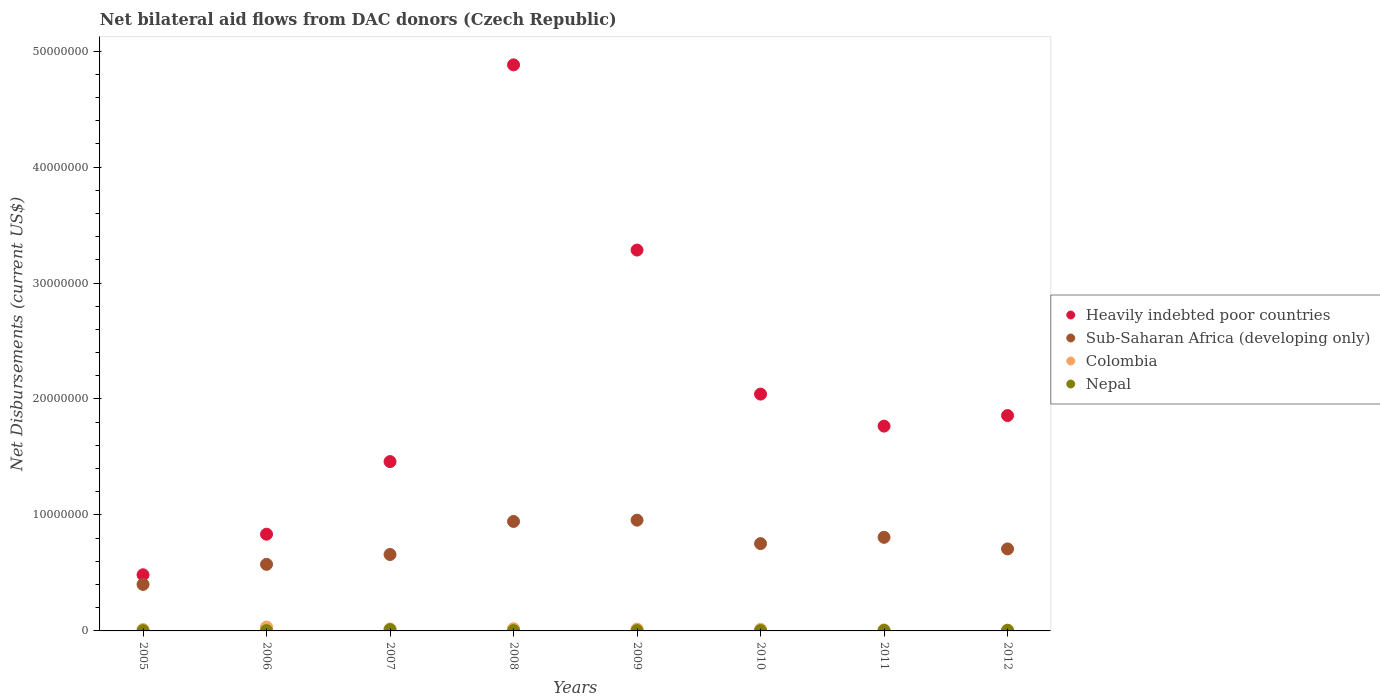How many different coloured dotlines are there?
Give a very brief answer. 4. Is the number of dotlines equal to the number of legend labels?
Keep it short and to the point. Yes. What is the net bilateral aid flows in Colombia in 2010?
Ensure brevity in your answer.  1.40e+05. Across all years, what is the maximum net bilateral aid flows in Colombia?
Make the answer very short. 3.30e+05. Across all years, what is the minimum net bilateral aid flows in Nepal?
Keep it short and to the point. 2.00e+04. In which year was the net bilateral aid flows in Sub-Saharan Africa (developing only) maximum?
Provide a succinct answer. 2009. What is the total net bilateral aid flows in Colombia in the graph?
Provide a short and direct response. 1.27e+06. What is the difference between the net bilateral aid flows in Heavily indebted poor countries in 2011 and that in 2012?
Keep it short and to the point. -9.10e+05. What is the difference between the net bilateral aid flows in Sub-Saharan Africa (developing only) in 2006 and the net bilateral aid flows in Colombia in 2010?
Give a very brief answer. 5.60e+06. What is the average net bilateral aid flows in Colombia per year?
Your response must be concise. 1.59e+05. In the year 2010, what is the difference between the net bilateral aid flows in Colombia and net bilateral aid flows in Nepal?
Provide a succinct answer. 1.10e+05. What is the ratio of the net bilateral aid flows in Colombia in 2007 to that in 2010?
Give a very brief answer. 1.21. Is the difference between the net bilateral aid flows in Colombia in 2009 and 2010 greater than the difference between the net bilateral aid flows in Nepal in 2009 and 2010?
Make the answer very short. Yes. What is the difference between the highest and the lowest net bilateral aid flows in Heavily indebted poor countries?
Provide a short and direct response. 4.40e+07. In how many years, is the net bilateral aid flows in Sub-Saharan Africa (developing only) greater than the average net bilateral aid flows in Sub-Saharan Africa (developing only) taken over all years?
Make the answer very short. 4. Is it the case that in every year, the sum of the net bilateral aid flows in Colombia and net bilateral aid flows in Nepal  is greater than the sum of net bilateral aid flows in Sub-Saharan Africa (developing only) and net bilateral aid flows in Heavily indebted poor countries?
Make the answer very short. Yes. Is it the case that in every year, the sum of the net bilateral aid flows in Heavily indebted poor countries and net bilateral aid flows in Sub-Saharan Africa (developing only)  is greater than the net bilateral aid flows in Nepal?
Provide a short and direct response. Yes. Is the net bilateral aid flows in Sub-Saharan Africa (developing only) strictly less than the net bilateral aid flows in Colombia over the years?
Your answer should be very brief. No. Does the graph contain any zero values?
Give a very brief answer. No. Does the graph contain grids?
Your response must be concise. No. How are the legend labels stacked?
Keep it short and to the point. Vertical. What is the title of the graph?
Your answer should be very brief. Net bilateral aid flows from DAC donors (Czech Republic). What is the label or title of the X-axis?
Make the answer very short. Years. What is the label or title of the Y-axis?
Offer a very short reply. Net Disbursements (current US$). What is the Net Disbursements (current US$) of Heavily indebted poor countries in 2005?
Make the answer very short. 4.84e+06. What is the Net Disbursements (current US$) in Sub-Saharan Africa (developing only) in 2005?
Offer a very short reply. 4.01e+06. What is the Net Disbursements (current US$) of Heavily indebted poor countries in 2006?
Provide a short and direct response. 8.34e+06. What is the Net Disbursements (current US$) of Sub-Saharan Africa (developing only) in 2006?
Your response must be concise. 5.74e+06. What is the Net Disbursements (current US$) in Nepal in 2006?
Your answer should be compact. 3.00e+04. What is the Net Disbursements (current US$) in Heavily indebted poor countries in 2007?
Keep it short and to the point. 1.46e+07. What is the Net Disbursements (current US$) of Sub-Saharan Africa (developing only) in 2007?
Your answer should be compact. 6.59e+06. What is the Net Disbursements (current US$) of Heavily indebted poor countries in 2008?
Provide a short and direct response. 4.88e+07. What is the Net Disbursements (current US$) in Sub-Saharan Africa (developing only) in 2008?
Your answer should be very brief. 9.44e+06. What is the Net Disbursements (current US$) in Colombia in 2008?
Offer a very short reply. 1.90e+05. What is the Net Disbursements (current US$) in Nepal in 2008?
Offer a very short reply. 3.00e+04. What is the Net Disbursements (current US$) of Heavily indebted poor countries in 2009?
Provide a succinct answer. 3.28e+07. What is the Net Disbursements (current US$) in Sub-Saharan Africa (developing only) in 2009?
Offer a terse response. 9.55e+06. What is the Net Disbursements (current US$) in Heavily indebted poor countries in 2010?
Your response must be concise. 2.04e+07. What is the Net Disbursements (current US$) of Sub-Saharan Africa (developing only) in 2010?
Your response must be concise. 7.53e+06. What is the Net Disbursements (current US$) of Heavily indebted poor countries in 2011?
Offer a very short reply. 1.77e+07. What is the Net Disbursements (current US$) in Sub-Saharan Africa (developing only) in 2011?
Keep it short and to the point. 8.07e+06. What is the Net Disbursements (current US$) in Colombia in 2011?
Offer a terse response. 9.00e+04. What is the Net Disbursements (current US$) in Heavily indebted poor countries in 2012?
Provide a short and direct response. 1.86e+07. What is the Net Disbursements (current US$) in Sub-Saharan Africa (developing only) in 2012?
Your response must be concise. 7.07e+06. What is the Net Disbursements (current US$) in Colombia in 2012?
Offer a terse response. 7.00e+04. What is the Net Disbursements (current US$) of Nepal in 2012?
Give a very brief answer. 5.00e+04. Across all years, what is the maximum Net Disbursements (current US$) in Heavily indebted poor countries?
Keep it short and to the point. 4.88e+07. Across all years, what is the maximum Net Disbursements (current US$) of Sub-Saharan Africa (developing only)?
Your response must be concise. 9.55e+06. Across all years, what is the maximum Net Disbursements (current US$) of Colombia?
Offer a very short reply. 3.30e+05. Across all years, what is the minimum Net Disbursements (current US$) in Heavily indebted poor countries?
Ensure brevity in your answer.  4.84e+06. Across all years, what is the minimum Net Disbursements (current US$) in Sub-Saharan Africa (developing only)?
Provide a short and direct response. 4.01e+06. Across all years, what is the minimum Net Disbursements (current US$) of Colombia?
Make the answer very short. 7.00e+04. Across all years, what is the minimum Net Disbursements (current US$) of Nepal?
Provide a succinct answer. 2.00e+04. What is the total Net Disbursements (current US$) of Heavily indebted poor countries in the graph?
Your answer should be very brief. 1.66e+08. What is the total Net Disbursements (current US$) of Sub-Saharan Africa (developing only) in the graph?
Give a very brief answer. 5.80e+07. What is the total Net Disbursements (current US$) of Colombia in the graph?
Your answer should be very brief. 1.27e+06. What is the difference between the Net Disbursements (current US$) in Heavily indebted poor countries in 2005 and that in 2006?
Your answer should be very brief. -3.50e+06. What is the difference between the Net Disbursements (current US$) of Sub-Saharan Africa (developing only) in 2005 and that in 2006?
Offer a very short reply. -1.73e+06. What is the difference between the Net Disbursements (current US$) in Colombia in 2005 and that in 2006?
Your response must be concise. -2.10e+05. What is the difference between the Net Disbursements (current US$) in Nepal in 2005 and that in 2006?
Your answer should be compact. -10000. What is the difference between the Net Disbursements (current US$) of Heavily indebted poor countries in 2005 and that in 2007?
Offer a terse response. -9.76e+06. What is the difference between the Net Disbursements (current US$) of Sub-Saharan Africa (developing only) in 2005 and that in 2007?
Give a very brief answer. -2.58e+06. What is the difference between the Net Disbursements (current US$) in Heavily indebted poor countries in 2005 and that in 2008?
Offer a terse response. -4.40e+07. What is the difference between the Net Disbursements (current US$) of Sub-Saharan Africa (developing only) in 2005 and that in 2008?
Your answer should be very brief. -5.43e+06. What is the difference between the Net Disbursements (current US$) of Heavily indebted poor countries in 2005 and that in 2009?
Keep it short and to the point. -2.80e+07. What is the difference between the Net Disbursements (current US$) of Sub-Saharan Africa (developing only) in 2005 and that in 2009?
Provide a short and direct response. -5.54e+06. What is the difference between the Net Disbursements (current US$) in Heavily indebted poor countries in 2005 and that in 2010?
Your response must be concise. -1.56e+07. What is the difference between the Net Disbursements (current US$) of Sub-Saharan Africa (developing only) in 2005 and that in 2010?
Keep it short and to the point. -3.52e+06. What is the difference between the Net Disbursements (current US$) in Colombia in 2005 and that in 2010?
Your answer should be compact. -2.00e+04. What is the difference between the Net Disbursements (current US$) in Nepal in 2005 and that in 2010?
Your response must be concise. -10000. What is the difference between the Net Disbursements (current US$) of Heavily indebted poor countries in 2005 and that in 2011?
Offer a terse response. -1.28e+07. What is the difference between the Net Disbursements (current US$) in Sub-Saharan Africa (developing only) in 2005 and that in 2011?
Your response must be concise. -4.06e+06. What is the difference between the Net Disbursements (current US$) of Colombia in 2005 and that in 2011?
Your answer should be compact. 3.00e+04. What is the difference between the Net Disbursements (current US$) of Heavily indebted poor countries in 2005 and that in 2012?
Keep it short and to the point. -1.37e+07. What is the difference between the Net Disbursements (current US$) of Sub-Saharan Africa (developing only) in 2005 and that in 2012?
Provide a succinct answer. -3.06e+06. What is the difference between the Net Disbursements (current US$) of Heavily indebted poor countries in 2006 and that in 2007?
Provide a succinct answer. -6.26e+06. What is the difference between the Net Disbursements (current US$) in Sub-Saharan Africa (developing only) in 2006 and that in 2007?
Give a very brief answer. -8.50e+05. What is the difference between the Net Disbursements (current US$) in Heavily indebted poor countries in 2006 and that in 2008?
Make the answer very short. -4.05e+07. What is the difference between the Net Disbursements (current US$) in Sub-Saharan Africa (developing only) in 2006 and that in 2008?
Give a very brief answer. -3.70e+06. What is the difference between the Net Disbursements (current US$) in Colombia in 2006 and that in 2008?
Your answer should be very brief. 1.40e+05. What is the difference between the Net Disbursements (current US$) in Heavily indebted poor countries in 2006 and that in 2009?
Make the answer very short. -2.45e+07. What is the difference between the Net Disbursements (current US$) of Sub-Saharan Africa (developing only) in 2006 and that in 2009?
Keep it short and to the point. -3.81e+06. What is the difference between the Net Disbursements (current US$) in Colombia in 2006 and that in 2009?
Your answer should be very brief. 1.70e+05. What is the difference between the Net Disbursements (current US$) of Heavily indebted poor countries in 2006 and that in 2010?
Keep it short and to the point. -1.21e+07. What is the difference between the Net Disbursements (current US$) in Sub-Saharan Africa (developing only) in 2006 and that in 2010?
Keep it short and to the point. -1.79e+06. What is the difference between the Net Disbursements (current US$) of Colombia in 2006 and that in 2010?
Make the answer very short. 1.90e+05. What is the difference between the Net Disbursements (current US$) in Nepal in 2006 and that in 2010?
Your response must be concise. 0. What is the difference between the Net Disbursements (current US$) in Heavily indebted poor countries in 2006 and that in 2011?
Offer a terse response. -9.32e+06. What is the difference between the Net Disbursements (current US$) in Sub-Saharan Africa (developing only) in 2006 and that in 2011?
Provide a succinct answer. -2.33e+06. What is the difference between the Net Disbursements (current US$) in Colombia in 2006 and that in 2011?
Ensure brevity in your answer.  2.40e+05. What is the difference between the Net Disbursements (current US$) in Nepal in 2006 and that in 2011?
Your answer should be very brief. -10000. What is the difference between the Net Disbursements (current US$) in Heavily indebted poor countries in 2006 and that in 2012?
Offer a very short reply. -1.02e+07. What is the difference between the Net Disbursements (current US$) in Sub-Saharan Africa (developing only) in 2006 and that in 2012?
Offer a terse response. -1.33e+06. What is the difference between the Net Disbursements (current US$) of Nepal in 2006 and that in 2012?
Offer a very short reply. -2.00e+04. What is the difference between the Net Disbursements (current US$) of Heavily indebted poor countries in 2007 and that in 2008?
Make the answer very short. -3.42e+07. What is the difference between the Net Disbursements (current US$) of Sub-Saharan Africa (developing only) in 2007 and that in 2008?
Offer a terse response. -2.85e+06. What is the difference between the Net Disbursements (current US$) in Nepal in 2007 and that in 2008?
Give a very brief answer. 8.00e+04. What is the difference between the Net Disbursements (current US$) of Heavily indebted poor countries in 2007 and that in 2009?
Your answer should be compact. -1.82e+07. What is the difference between the Net Disbursements (current US$) of Sub-Saharan Africa (developing only) in 2007 and that in 2009?
Provide a short and direct response. -2.96e+06. What is the difference between the Net Disbursements (current US$) in Colombia in 2007 and that in 2009?
Offer a terse response. 10000. What is the difference between the Net Disbursements (current US$) of Nepal in 2007 and that in 2009?
Your answer should be compact. 8.00e+04. What is the difference between the Net Disbursements (current US$) of Heavily indebted poor countries in 2007 and that in 2010?
Make the answer very short. -5.82e+06. What is the difference between the Net Disbursements (current US$) of Sub-Saharan Africa (developing only) in 2007 and that in 2010?
Offer a very short reply. -9.40e+05. What is the difference between the Net Disbursements (current US$) of Colombia in 2007 and that in 2010?
Give a very brief answer. 3.00e+04. What is the difference between the Net Disbursements (current US$) in Heavily indebted poor countries in 2007 and that in 2011?
Make the answer very short. -3.06e+06. What is the difference between the Net Disbursements (current US$) of Sub-Saharan Africa (developing only) in 2007 and that in 2011?
Your response must be concise. -1.48e+06. What is the difference between the Net Disbursements (current US$) in Nepal in 2007 and that in 2011?
Offer a very short reply. 7.00e+04. What is the difference between the Net Disbursements (current US$) in Heavily indebted poor countries in 2007 and that in 2012?
Your answer should be very brief. -3.97e+06. What is the difference between the Net Disbursements (current US$) of Sub-Saharan Africa (developing only) in 2007 and that in 2012?
Your answer should be compact. -4.80e+05. What is the difference between the Net Disbursements (current US$) in Nepal in 2007 and that in 2012?
Offer a very short reply. 6.00e+04. What is the difference between the Net Disbursements (current US$) of Heavily indebted poor countries in 2008 and that in 2009?
Your answer should be very brief. 1.60e+07. What is the difference between the Net Disbursements (current US$) of Nepal in 2008 and that in 2009?
Give a very brief answer. 0. What is the difference between the Net Disbursements (current US$) in Heavily indebted poor countries in 2008 and that in 2010?
Offer a very short reply. 2.84e+07. What is the difference between the Net Disbursements (current US$) of Sub-Saharan Africa (developing only) in 2008 and that in 2010?
Your answer should be compact. 1.91e+06. What is the difference between the Net Disbursements (current US$) of Colombia in 2008 and that in 2010?
Offer a very short reply. 5.00e+04. What is the difference between the Net Disbursements (current US$) in Heavily indebted poor countries in 2008 and that in 2011?
Make the answer very short. 3.12e+07. What is the difference between the Net Disbursements (current US$) in Sub-Saharan Africa (developing only) in 2008 and that in 2011?
Provide a succinct answer. 1.37e+06. What is the difference between the Net Disbursements (current US$) in Colombia in 2008 and that in 2011?
Ensure brevity in your answer.  1.00e+05. What is the difference between the Net Disbursements (current US$) of Heavily indebted poor countries in 2008 and that in 2012?
Make the answer very short. 3.02e+07. What is the difference between the Net Disbursements (current US$) in Sub-Saharan Africa (developing only) in 2008 and that in 2012?
Offer a very short reply. 2.37e+06. What is the difference between the Net Disbursements (current US$) in Colombia in 2008 and that in 2012?
Offer a very short reply. 1.20e+05. What is the difference between the Net Disbursements (current US$) in Nepal in 2008 and that in 2012?
Offer a very short reply. -2.00e+04. What is the difference between the Net Disbursements (current US$) of Heavily indebted poor countries in 2009 and that in 2010?
Keep it short and to the point. 1.24e+07. What is the difference between the Net Disbursements (current US$) in Sub-Saharan Africa (developing only) in 2009 and that in 2010?
Your answer should be very brief. 2.02e+06. What is the difference between the Net Disbursements (current US$) in Colombia in 2009 and that in 2010?
Provide a succinct answer. 2.00e+04. What is the difference between the Net Disbursements (current US$) in Heavily indebted poor countries in 2009 and that in 2011?
Provide a short and direct response. 1.52e+07. What is the difference between the Net Disbursements (current US$) of Sub-Saharan Africa (developing only) in 2009 and that in 2011?
Provide a short and direct response. 1.48e+06. What is the difference between the Net Disbursements (current US$) of Colombia in 2009 and that in 2011?
Make the answer very short. 7.00e+04. What is the difference between the Net Disbursements (current US$) in Nepal in 2009 and that in 2011?
Offer a terse response. -10000. What is the difference between the Net Disbursements (current US$) in Heavily indebted poor countries in 2009 and that in 2012?
Offer a terse response. 1.43e+07. What is the difference between the Net Disbursements (current US$) in Sub-Saharan Africa (developing only) in 2009 and that in 2012?
Keep it short and to the point. 2.48e+06. What is the difference between the Net Disbursements (current US$) of Heavily indebted poor countries in 2010 and that in 2011?
Give a very brief answer. 2.76e+06. What is the difference between the Net Disbursements (current US$) in Sub-Saharan Africa (developing only) in 2010 and that in 2011?
Your answer should be very brief. -5.40e+05. What is the difference between the Net Disbursements (current US$) in Heavily indebted poor countries in 2010 and that in 2012?
Your response must be concise. 1.85e+06. What is the difference between the Net Disbursements (current US$) of Colombia in 2010 and that in 2012?
Ensure brevity in your answer.  7.00e+04. What is the difference between the Net Disbursements (current US$) of Heavily indebted poor countries in 2011 and that in 2012?
Offer a terse response. -9.10e+05. What is the difference between the Net Disbursements (current US$) of Sub-Saharan Africa (developing only) in 2011 and that in 2012?
Give a very brief answer. 1.00e+06. What is the difference between the Net Disbursements (current US$) of Nepal in 2011 and that in 2012?
Provide a short and direct response. -10000. What is the difference between the Net Disbursements (current US$) of Heavily indebted poor countries in 2005 and the Net Disbursements (current US$) of Sub-Saharan Africa (developing only) in 2006?
Offer a terse response. -9.00e+05. What is the difference between the Net Disbursements (current US$) in Heavily indebted poor countries in 2005 and the Net Disbursements (current US$) in Colombia in 2006?
Your answer should be compact. 4.51e+06. What is the difference between the Net Disbursements (current US$) in Heavily indebted poor countries in 2005 and the Net Disbursements (current US$) in Nepal in 2006?
Provide a succinct answer. 4.81e+06. What is the difference between the Net Disbursements (current US$) of Sub-Saharan Africa (developing only) in 2005 and the Net Disbursements (current US$) of Colombia in 2006?
Give a very brief answer. 3.68e+06. What is the difference between the Net Disbursements (current US$) of Sub-Saharan Africa (developing only) in 2005 and the Net Disbursements (current US$) of Nepal in 2006?
Offer a terse response. 3.98e+06. What is the difference between the Net Disbursements (current US$) of Colombia in 2005 and the Net Disbursements (current US$) of Nepal in 2006?
Give a very brief answer. 9.00e+04. What is the difference between the Net Disbursements (current US$) of Heavily indebted poor countries in 2005 and the Net Disbursements (current US$) of Sub-Saharan Africa (developing only) in 2007?
Your answer should be compact. -1.75e+06. What is the difference between the Net Disbursements (current US$) in Heavily indebted poor countries in 2005 and the Net Disbursements (current US$) in Colombia in 2007?
Your response must be concise. 4.67e+06. What is the difference between the Net Disbursements (current US$) in Heavily indebted poor countries in 2005 and the Net Disbursements (current US$) in Nepal in 2007?
Make the answer very short. 4.73e+06. What is the difference between the Net Disbursements (current US$) in Sub-Saharan Africa (developing only) in 2005 and the Net Disbursements (current US$) in Colombia in 2007?
Your answer should be very brief. 3.84e+06. What is the difference between the Net Disbursements (current US$) of Sub-Saharan Africa (developing only) in 2005 and the Net Disbursements (current US$) of Nepal in 2007?
Your answer should be compact. 3.90e+06. What is the difference between the Net Disbursements (current US$) in Colombia in 2005 and the Net Disbursements (current US$) in Nepal in 2007?
Offer a terse response. 10000. What is the difference between the Net Disbursements (current US$) of Heavily indebted poor countries in 2005 and the Net Disbursements (current US$) of Sub-Saharan Africa (developing only) in 2008?
Ensure brevity in your answer.  -4.60e+06. What is the difference between the Net Disbursements (current US$) of Heavily indebted poor countries in 2005 and the Net Disbursements (current US$) of Colombia in 2008?
Offer a terse response. 4.65e+06. What is the difference between the Net Disbursements (current US$) in Heavily indebted poor countries in 2005 and the Net Disbursements (current US$) in Nepal in 2008?
Make the answer very short. 4.81e+06. What is the difference between the Net Disbursements (current US$) of Sub-Saharan Africa (developing only) in 2005 and the Net Disbursements (current US$) of Colombia in 2008?
Provide a succinct answer. 3.82e+06. What is the difference between the Net Disbursements (current US$) of Sub-Saharan Africa (developing only) in 2005 and the Net Disbursements (current US$) of Nepal in 2008?
Make the answer very short. 3.98e+06. What is the difference between the Net Disbursements (current US$) in Heavily indebted poor countries in 2005 and the Net Disbursements (current US$) in Sub-Saharan Africa (developing only) in 2009?
Offer a terse response. -4.71e+06. What is the difference between the Net Disbursements (current US$) in Heavily indebted poor countries in 2005 and the Net Disbursements (current US$) in Colombia in 2009?
Your answer should be very brief. 4.68e+06. What is the difference between the Net Disbursements (current US$) of Heavily indebted poor countries in 2005 and the Net Disbursements (current US$) of Nepal in 2009?
Provide a succinct answer. 4.81e+06. What is the difference between the Net Disbursements (current US$) in Sub-Saharan Africa (developing only) in 2005 and the Net Disbursements (current US$) in Colombia in 2009?
Your response must be concise. 3.85e+06. What is the difference between the Net Disbursements (current US$) of Sub-Saharan Africa (developing only) in 2005 and the Net Disbursements (current US$) of Nepal in 2009?
Your answer should be very brief. 3.98e+06. What is the difference between the Net Disbursements (current US$) of Colombia in 2005 and the Net Disbursements (current US$) of Nepal in 2009?
Your answer should be very brief. 9.00e+04. What is the difference between the Net Disbursements (current US$) of Heavily indebted poor countries in 2005 and the Net Disbursements (current US$) of Sub-Saharan Africa (developing only) in 2010?
Your response must be concise. -2.69e+06. What is the difference between the Net Disbursements (current US$) in Heavily indebted poor countries in 2005 and the Net Disbursements (current US$) in Colombia in 2010?
Provide a succinct answer. 4.70e+06. What is the difference between the Net Disbursements (current US$) in Heavily indebted poor countries in 2005 and the Net Disbursements (current US$) in Nepal in 2010?
Keep it short and to the point. 4.81e+06. What is the difference between the Net Disbursements (current US$) of Sub-Saharan Africa (developing only) in 2005 and the Net Disbursements (current US$) of Colombia in 2010?
Keep it short and to the point. 3.87e+06. What is the difference between the Net Disbursements (current US$) in Sub-Saharan Africa (developing only) in 2005 and the Net Disbursements (current US$) in Nepal in 2010?
Your answer should be compact. 3.98e+06. What is the difference between the Net Disbursements (current US$) in Colombia in 2005 and the Net Disbursements (current US$) in Nepal in 2010?
Your answer should be compact. 9.00e+04. What is the difference between the Net Disbursements (current US$) of Heavily indebted poor countries in 2005 and the Net Disbursements (current US$) of Sub-Saharan Africa (developing only) in 2011?
Your answer should be compact. -3.23e+06. What is the difference between the Net Disbursements (current US$) of Heavily indebted poor countries in 2005 and the Net Disbursements (current US$) of Colombia in 2011?
Give a very brief answer. 4.75e+06. What is the difference between the Net Disbursements (current US$) in Heavily indebted poor countries in 2005 and the Net Disbursements (current US$) in Nepal in 2011?
Your answer should be compact. 4.80e+06. What is the difference between the Net Disbursements (current US$) in Sub-Saharan Africa (developing only) in 2005 and the Net Disbursements (current US$) in Colombia in 2011?
Provide a short and direct response. 3.92e+06. What is the difference between the Net Disbursements (current US$) of Sub-Saharan Africa (developing only) in 2005 and the Net Disbursements (current US$) of Nepal in 2011?
Offer a terse response. 3.97e+06. What is the difference between the Net Disbursements (current US$) in Heavily indebted poor countries in 2005 and the Net Disbursements (current US$) in Sub-Saharan Africa (developing only) in 2012?
Provide a short and direct response. -2.23e+06. What is the difference between the Net Disbursements (current US$) in Heavily indebted poor countries in 2005 and the Net Disbursements (current US$) in Colombia in 2012?
Provide a succinct answer. 4.77e+06. What is the difference between the Net Disbursements (current US$) of Heavily indebted poor countries in 2005 and the Net Disbursements (current US$) of Nepal in 2012?
Offer a terse response. 4.79e+06. What is the difference between the Net Disbursements (current US$) of Sub-Saharan Africa (developing only) in 2005 and the Net Disbursements (current US$) of Colombia in 2012?
Offer a very short reply. 3.94e+06. What is the difference between the Net Disbursements (current US$) in Sub-Saharan Africa (developing only) in 2005 and the Net Disbursements (current US$) in Nepal in 2012?
Keep it short and to the point. 3.96e+06. What is the difference between the Net Disbursements (current US$) in Heavily indebted poor countries in 2006 and the Net Disbursements (current US$) in Sub-Saharan Africa (developing only) in 2007?
Your response must be concise. 1.75e+06. What is the difference between the Net Disbursements (current US$) of Heavily indebted poor countries in 2006 and the Net Disbursements (current US$) of Colombia in 2007?
Your answer should be compact. 8.17e+06. What is the difference between the Net Disbursements (current US$) of Heavily indebted poor countries in 2006 and the Net Disbursements (current US$) of Nepal in 2007?
Ensure brevity in your answer.  8.23e+06. What is the difference between the Net Disbursements (current US$) of Sub-Saharan Africa (developing only) in 2006 and the Net Disbursements (current US$) of Colombia in 2007?
Provide a succinct answer. 5.57e+06. What is the difference between the Net Disbursements (current US$) of Sub-Saharan Africa (developing only) in 2006 and the Net Disbursements (current US$) of Nepal in 2007?
Offer a terse response. 5.63e+06. What is the difference between the Net Disbursements (current US$) of Colombia in 2006 and the Net Disbursements (current US$) of Nepal in 2007?
Keep it short and to the point. 2.20e+05. What is the difference between the Net Disbursements (current US$) of Heavily indebted poor countries in 2006 and the Net Disbursements (current US$) of Sub-Saharan Africa (developing only) in 2008?
Keep it short and to the point. -1.10e+06. What is the difference between the Net Disbursements (current US$) of Heavily indebted poor countries in 2006 and the Net Disbursements (current US$) of Colombia in 2008?
Keep it short and to the point. 8.15e+06. What is the difference between the Net Disbursements (current US$) of Heavily indebted poor countries in 2006 and the Net Disbursements (current US$) of Nepal in 2008?
Offer a very short reply. 8.31e+06. What is the difference between the Net Disbursements (current US$) in Sub-Saharan Africa (developing only) in 2006 and the Net Disbursements (current US$) in Colombia in 2008?
Provide a short and direct response. 5.55e+06. What is the difference between the Net Disbursements (current US$) of Sub-Saharan Africa (developing only) in 2006 and the Net Disbursements (current US$) of Nepal in 2008?
Provide a succinct answer. 5.71e+06. What is the difference between the Net Disbursements (current US$) of Heavily indebted poor countries in 2006 and the Net Disbursements (current US$) of Sub-Saharan Africa (developing only) in 2009?
Ensure brevity in your answer.  -1.21e+06. What is the difference between the Net Disbursements (current US$) of Heavily indebted poor countries in 2006 and the Net Disbursements (current US$) of Colombia in 2009?
Give a very brief answer. 8.18e+06. What is the difference between the Net Disbursements (current US$) of Heavily indebted poor countries in 2006 and the Net Disbursements (current US$) of Nepal in 2009?
Provide a succinct answer. 8.31e+06. What is the difference between the Net Disbursements (current US$) of Sub-Saharan Africa (developing only) in 2006 and the Net Disbursements (current US$) of Colombia in 2009?
Ensure brevity in your answer.  5.58e+06. What is the difference between the Net Disbursements (current US$) of Sub-Saharan Africa (developing only) in 2006 and the Net Disbursements (current US$) of Nepal in 2009?
Provide a succinct answer. 5.71e+06. What is the difference between the Net Disbursements (current US$) in Heavily indebted poor countries in 2006 and the Net Disbursements (current US$) in Sub-Saharan Africa (developing only) in 2010?
Ensure brevity in your answer.  8.10e+05. What is the difference between the Net Disbursements (current US$) of Heavily indebted poor countries in 2006 and the Net Disbursements (current US$) of Colombia in 2010?
Provide a short and direct response. 8.20e+06. What is the difference between the Net Disbursements (current US$) in Heavily indebted poor countries in 2006 and the Net Disbursements (current US$) in Nepal in 2010?
Your answer should be compact. 8.31e+06. What is the difference between the Net Disbursements (current US$) in Sub-Saharan Africa (developing only) in 2006 and the Net Disbursements (current US$) in Colombia in 2010?
Offer a very short reply. 5.60e+06. What is the difference between the Net Disbursements (current US$) in Sub-Saharan Africa (developing only) in 2006 and the Net Disbursements (current US$) in Nepal in 2010?
Ensure brevity in your answer.  5.71e+06. What is the difference between the Net Disbursements (current US$) of Colombia in 2006 and the Net Disbursements (current US$) of Nepal in 2010?
Ensure brevity in your answer.  3.00e+05. What is the difference between the Net Disbursements (current US$) in Heavily indebted poor countries in 2006 and the Net Disbursements (current US$) in Sub-Saharan Africa (developing only) in 2011?
Offer a terse response. 2.70e+05. What is the difference between the Net Disbursements (current US$) in Heavily indebted poor countries in 2006 and the Net Disbursements (current US$) in Colombia in 2011?
Provide a succinct answer. 8.25e+06. What is the difference between the Net Disbursements (current US$) in Heavily indebted poor countries in 2006 and the Net Disbursements (current US$) in Nepal in 2011?
Your response must be concise. 8.30e+06. What is the difference between the Net Disbursements (current US$) in Sub-Saharan Africa (developing only) in 2006 and the Net Disbursements (current US$) in Colombia in 2011?
Offer a very short reply. 5.65e+06. What is the difference between the Net Disbursements (current US$) in Sub-Saharan Africa (developing only) in 2006 and the Net Disbursements (current US$) in Nepal in 2011?
Your response must be concise. 5.70e+06. What is the difference between the Net Disbursements (current US$) in Heavily indebted poor countries in 2006 and the Net Disbursements (current US$) in Sub-Saharan Africa (developing only) in 2012?
Your answer should be very brief. 1.27e+06. What is the difference between the Net Disbursements (current US$) of Heavily indebted poor countries in 2006 and the Net Disbursements (current US$) of Colombia in 2012?
Provide a succinct answer. 8.27e+06. What is the difference between the Net Disbursements (current US$) of Heavily indebted poor countries in 2006 and the Net Disbursements (current US$) of Nepal in 2012?
Ensure brevity in your answer.  8.29e+06. What is the difference between the Net Disbursements (current US$) in Sub-Saharan Africa (developing only) in 2006 and the Net Disbursements (current US$) in Colombia in 2012?
Keep it short and to the point. 5.67e+06. What is the difference between the Net Disbursements (current US$) in Sub-Saharan Africa (developing only) in 2006 and the Net Disbursements (current US$) in Nepal in 2012?
Make the answer very short. 5.69e+06. What is the difference between the Net Disbursements (current US$) in Colombia in 2006 and the Net Disbursements (current US$) in Nepal in 2012?
Offer a terse response. 2.80e+05. What is the difference between the Net Disbursements (current US$) in Heavily indebted poor countries in 2007 and the Net Disbursements (current US$) in Sub-Saharan Africa (developing only) in 2008?
Your answer should be very brief. 5.16e+06. What is the difference between the Net Disbursements (current US$) of Heavily indebted poor countries in 2007 and the Net Disbursements (current US$) of Colombia in 2008?
Make the answer very short. 1.44e+07. What is the difference between the Net Disbursements (current US$) in Heavily indebted poor countries in 2007 and the Net Disbursements (current US$) in Nepal in 2008?
Your answer should be very brief. 1.46e+07. What is the difference between the Net Disbursements (current US$) of Sub-Saharan Africa (developing only) in 2007 and the Net Disbursements (current US$) of Colombia in 2008?
Provide a succinct answer. 6.40e+06. What is the difference between the Net Disbursements (current US$) of Sub-Saharan Africa (developing only) in 2007 and the Net Disbursements (current US$) of Nepal in 2008?
Your response must be concise. 6.56e+06. What is the difference between the Net Disbursements (current US$) in Colombia in 2007 and the Net Disbursements (current US$) in Nepal in 2008?
Provide a short and direct response. 1.40e+05. What is the difference between the Net Disbursements (current US$) of Heavily indebted poor countries in 2007 and the Net Disbursements (current US$) of Sub-Saharan Africa (developing only) in 2009?
Keep it short and to the point. 5.05e+06. What is the difference between the Net Disbursements (current US$) of Heavily indebted poor countries in 2007 and the Net Disbursements (current US$) of Colombia in 2009?
Ensure brevity in your answer.  1.44e+07. What is the difference between the Net Disbursements (current US$) of Heavily indebted poor countries in 2007 and the Net Disbursements (current US$) of Nepal in 2009?
Provide a short and direct response. 1.46e+07. What is the difference between the Net Disbursements (current US$) in Sub-Saharan Africa (developing only) in 2007 and the Net Disbursements (current US$) in Colombia in 2009?
Your answer should be compact. 6.43e+06. What is the difference between the Net Disbursements (current US$) in Sub-Saharan Africa (developing only) in 2007 and the Net Disbursements (current US$) in Nepal in 2009?
Make the answer very short. 6.56e+06. What is the difference between the Net Disbursements (current US$) in Colombia in 2007 and the Net Disbursements (current US$) in Nepal in 2009?
Ensure brevity in your answer.  1.40e+05. What is the difference between the Net Disbursements (current US$) in Heavily indebted poor countries in 2007 and the Net Disbursements (current US$) in Sub-Saharan Africa (developing only) in 2010?
Ensure brevity in your answer.  7.07e+06. What is the difference between the Net Disbursements (current US$) in Heavily indebted poor countries in 2007 and the Net Disbursements (current US$) in Colombia in 2010?
Provide a succinct answer. 1.45e+07. What is the difference between the Net Disbursements (current US$) of Heavily indebted poor countries in 2007 and the Net Disbursements (current US$) of Nepal in 2010?
Your answer should be very brief. 1.46e+07. What is the difference between the Net Disbursements (current US$) in Sub-Saharan Africa (developing only) in 2007 and the Net Disbursements (current US$) in Colombia in 2010?
Your answer should be very brief. 6.45e+06. What is the difference between the Net Disbursements (current US$) in Sub-Saharan Africa (developing only) in 2007 and the Net Disbursements (current US$) in Nepal in 2010?
Offer a very short reply. 6.56e+06. What is the difference between the Net Disbursements (current US$) of Heavily indebted poor countries in 2007 and the Net Disbursements (current US$) of Sub-Saharan Africa (developing only) in 2011?
Make the answer very short. 6.53e+06. What is the difference between the Net Disbursements (current US$) of Heavily indebted poor countries in 2007 and the Net Disbursements (current US$) of Colombia in 2011?
Make the answer very short. 1.45e+07. What is the difference between the Net Disbursements (current US$) in Heavily indebted poor countries in 2007 and the Net Disbursements (current US$) in Nepal in 2011?
Your answer should be compact. 1.46e+07. What is the difference between the Net Disbursements (current US$) in Sub-Saharan Africa (developing only) in 2007 and the Net Disbursements (current US$) in Colombia in 2011?
Give a very brief answer. 6.50e+06. What is the difference between the Net Disbursements (current US$) of Sub-Saharan Africa (developing only) in 2007 and the Net Disbursements (current US$) of Nepal in 2011?
Keep it short and to the point. 6.55e+06. What is the difference between the Net Disbursements (current US$) of Colombia in 2007 and the Net Disbursements (current US$) of Nepal in 2011?
Offer a terse response. 1.30e+05. What is the difference between the Net Disbursements (current US$) of Heavily indebted poor countries in 2007 and the Net Disbursements (current US$) of Sub-Saharan Africa (developing only) in 2012?
Provide a short and direct response. 7.53e+06. What is the difference between the Net Disbursements (current US$) in Heavily indebted poor countries in 2007 and the Net Disbursements (current US$) in Colombia in 2012?
Offer a terse response. 1.45e+07. What is the difference between the Net Disbursements (current US$) of Heavily indebted poor countries in 2007 and the Net Disbursements (current US$) of Nepal in 2012?
Make the answer very short. 1.46e+07. What is the difference between the Net Disbursements (current US$) in Sub-Saharan Africa (developing only) in 2007 and the Net Disbursements (current US$) in Colombia in 2012?
Provide a succinct answer. 6.52e+06. What is the difference between the Net Disbursements (current US$) in Sub-Saharan Africa (developing only) in 2007 and the Net Disbursements (current US$) in Nepal in 2012?
Your answer should be very brief. 6.54e+06. What is the difference between the Net Disbursements (current US$) in Colombia in 2007 and the Net Disbursements (current US$) in Nepal in 2012?
Ensure brevity in your answer.  1.20e+05. What is the difference between the Net Disbursements (current US$) of Heavily indebted poor countries in 2008 and the Net Disbursements (current US$) of Sub-Saharan Africa (developing only) in 2009?
Make the answer very short. 3.93e+07. What is the difference between the Net Disbursements (current US$) of Heavily indebted poor countries in 2008 and the Net Disbursements (current US$) of Colombia in 2009?
Make the answer very short. 4.86e+07. What is the difference between the Net Disbursements (current US$) in Heavily indebted poor countries in 2008 and the Net Disbursements (current US$) in Nepal in 2009?
Provide a succinct answer. 4.88e+07. What is the difference between the Net Disbursements (current US$) of Sub-Saharan Africa (developing only) in 2008 and the Net Disbursements (current US$) of Colombia in 2009?
Provide a short and direct response. 9.28e+06. What is the difference between the Net Disbursements (current US$) of Sub-Saharan Africa (developing only) in 2008 and the Net Disbursements (current US$) of Nepal in 2009?
Your answer should be compact. 9.41e+06. What is the difference between the Net Disbursements (current US$) of Heavily indebted poor countries in 2008 and the Net Disbursements (current US$) of Sub-Saharan Africa (developing only) in 2010?
Give a very brief answer. 4.13e+07. What is the difference between the Net Disbursements (current US$) in Heavily indebted poor countries in 2008 and the Net Disbursements (current US$) in Colombia in 2010?
Offer a terse response. 4.87e+07. What is the difference between the Net Disbursements (current US$) of Heavily indebted poor countries in 2008 and the Net Disbursements (current US$) of Nepal in 2010?
Provide a short and direct response. 4.88e+07. What is the difference between the Net Disbursements (current US$) of Sub-Saharan Africa (developing only) in 2008 and the Net Disbursements (current US$) of Colombia in 2010?
Offer a terse response. 9.30e+06. What is the difference between the Net Disbursements (current US$) of Sub-Saharan Africa (developing only) in 2008 and the Net Disbursements (current US$) of Nepal in 2010?
Your answer should be very brief. 9.41e+06. What is the difference between the Net Disbursements (current US$) in Heavily indebted poor countries in 2008 and the Net Disbursements (current US$) in Sub-Saharan Africa (developing only) in 2011?
Your answer should be compact. 4.07e+07. What is the difference between the Net Disbursements (current US$) in Heavily indebted poor countries in 2008 and the Net Disbursements (current US$) in Colombia in 2011?
Provide a succinct answer. 4.87e+07. What is the difference between the Net Disbursements (current US$) of Heavily indebted poor countries in 2008 and the Net Disbursements (current US$) of Nepal in 2011?
Provide a succinct answer. 4.88e+07. What is the difference between the Net Disbursements (current US$) in Sub-Saharan Africa (developing only) in 2008 and the Net Disbursements (current US$) in Colombia in 2011?
Provide a succinct answer. 9.35e+06. What is the difference between the Net Disbursements (current US$) of Sub-Saharan Africa (developing only) in 2008 and the Net Disbursements (current US$) of Nepal in 2011?
Provide a short and direct response. 9.40e+06. What is the difference between the Net Disbursements (current US$) of Heavily indebted poor countries in 2008 and the Net Disbursements (current US$) of Sub-Saharan Africa (developing only) in 2012?
Keep it short and to the point. 4.17e+07. What is the difference between the Net Disbursements (current US$) in Heavily indebted poor countries in 2008 and the Net Disbursements (current US$) in Colombia in 2012?
Provide a succinct answer. 4.87e+07. What is the difference between the Net Disbursements (current US$) of Heavily indebted poor countries in 2008 and the Net Disbursements (current US$) of Nepal in 2012?
Give a very brief answer. 4.88e+07. What is the difference between the Net Disbursements (current US$) in Sub-Saharan Africa (developing only) in 2008 and the Net Disbursements (current US$) in Colombia in 2012?
Provide a short and direct response. 9.37e+06. What is the difference between the Net Disbursements (current US$) of Sub-Saharan Africa (developing only) in 2008 and the Net Disbursements (current US$) of Nepal in 2012?
Ensure brevity in your answer.  9.39e+06. What is the difference between the Net Disbursements (current US$) of Heavily indebted poor countries in 2009 and the Net Disbursements (current US$) of Sub-Saharan Africa (developing only) in 2010?
Provide a succinct answer. 2.53e+07. What is the difference between the Net Disbursements (current US$) in Heavily indebted poor countries in 2009 and the Net Disbursements (current US$) in Colombia in 2010?
Provide a short and direct response. 3.27e+07. What is the difference between the Net Disbursements (current US$) of Heavily indebted poor countries in 2009 and the Net Disbursements (current US$) of Nepal in 2010?
Your answer should be compact. 3.28e+07. What is the difference between the Net Disbursements (current US$) in Sub-Saharan Africa (developing only) in 2009 and the Net Disbursements (current US$) in Colombia in 2010?
Ensure brevity in your answer.  9.41e+06. What is the difference between the Net Disbursements (current US$) of Sub-Saharan Africa (developing only) in 2009 and the Net Disbursements (current US$) of Nepal in 2010?
Your response must be concise. 9.52e+06. What is the difference between the Net Disbursements (current US$) in Heavily indebted poor countries in 2009 and the Net Disbursements (current US$) in Sub-Saharan Africa (developing only) in 2011?
Ensure brevity in your answer.  2.48e+07. What is the difference between the Net Disbursements (current US$) of Heavily indebted poor countries in 2009 and the Net Disbursements (current US$) of Colombia in 2011?
Your answer should be compact. 3.28e+07. What is the difference between the Net Disbursements (current US$) in Heavily indebted poor countries in 2009 and the Net Disbursements (current US$) in Nepal in 2011?
Provide a succinct answer. 3.28e+07. What is the difference between the Net Disbursements (current US$) in Sub-Saharan Africa (developing only) in 2009 and the Net Disbursements (current US$) in Colombia in 2011?
Offer a terse response. 9.46e+06. What is the difference between the Net Disbursements (current US$) in Sub-Saharan Africa (developing only) in 2009 and the Net Disbursements (current US$) in Nepal in 2011?
Offer a terse response. 9.51e+06. What is the difference between the Net Disbursements (current US$) of Colombia in 2009 and the Net Disbursements (current US$) of Nepal in 2011?
Provide a short and direct response. 1.20e+05. What is the difference between the Net Disbursements (current US$) in Heavily indebted poor countries in 2009 and the Net Disbursements (current US$) in Sub-Saharan Africa (developing only) in 2012?
Provide a short and direct response. 2.58e+07. What is the difference between the Net Disbursements (current US$) of Heavily indebted poor countries in 2009 and the Net Disbursements (current US$) of Colombia in 2012?
Your response must be concise. 3.28e+07. What is the difference between the Net Disbursements (current US$) of Heavily indebted poor countries in 2009 and the Net Disbursements (current US$) of Nepal in 2012?
Keep it short and to the point. 3.28e+07. What is the difference between the Net Disbursements (current US$) in Sub-Saharan Africa (developing only) in 2009 and the Net Disbursements (current US$) in Colombia in 2012?
Your answer should be compact. 9.48e+06. What is the difference between the Net Disbursements (current US$) of Sub-Saharan Africa (developing only) in 2009 and the Net Disbursements (current US$) of Nepal in 2012?
Offer a very short reply. 9.50e+06. What is the difference between the Net Disbursements (current US$) in Heavily indebted poor countries in 2010 and the Net Disbursements (current US$) in Sub-Saharan Africa (developing only) in 2011?
Offer a terse response. 1.24e+07. What is the difference between the Net Disbursements (current US$) in Heavily indebted poor countries in 2010 and the Net Disbursements (current US$) in Colombia in 2011?
Keep it short and to the point. 2.03e+07. What is the difference between the Net Disbursements (current US$) of Heavily indebted poor countries in 2010 and the Net Disbursements (current US$) of Nepal in 2011?
Your answer should be very brief. 2.04e+07. What is the difference between the Net Disbursements (current US$) in Sub-Saharan Africa (developing only) in 2010 and the Net Disbursements (current US$) in Colombia in 2011?
Ensure brevity in your answer.  7.44e+06. What is the difference between the Net Disbursements (current US$) of Sub-Saharan Africa (developing only) in 2010 and the Net Disbursements (current US$) of Nepal in 2011?
Ensure brevity in your answer.  7.49e+06. What is the difference between the Net Disbursements (current US$) of Colombia in 2010 and the Net Disbursements (current US$) of Nepal in 2011?
Your response must be concise. 1.00e+05. What is the difference between the Net Disbursements (current US$) in Heavily indebted poor countries in 2010 and the Net Disbursements (current US$) in Sub-Saharan Africa (developing only) in 2012?
Make the answer very short. 1.34e+07. What is the difference between the Net Disbursements (current US$) in Heavily indebted poor countries in 2010 and the Net Disbursements (current US$) in Colombia in 2012?
Give a very brief answer. 2.04e+07. What is the difference between the Net Disbursements (current US$) of Heavily indebted poor countries in 2010 and the Net Disbursements (current US$) of Nepal in 2012?
Offer a terse response. 2.04e+07. What is the difference between the Net Disbursements (current US$) in Sub-Saharan Africa (developing only) in 2010 and the Net Disbursements (current US$) in Colombia in 2012?
Your answer should be very brief. 7.46e+06. What is the difference between the Net Disbursements (current US$) in Sub-Saharan Africa (developing only) in 2010 and the Net Disbursements (current US$) in Nepal in 2012?
Provide a succinct answer. 7.48e+06. What is the difference between the Net Disbursements (current US$) of Heavily indebted poor countries in 2011 and the Net Disbursements (current US$) of Sub-Saharan Africa (developing only) in 2012?
Your answer should be compact. 1.06e+07. What is the difference between the Net Disbursements (current US$) in Heavily indebted poor countries in 2011 and the Net Disbursements (current US$) in Colombia in 2012?
Provide a short and direct response. 1.76e+07. What is the difference between the Net Disbursements (current US$) in Heavily indebted poor countries in 2011 and the Net Disbursements (current US$) in Nepal in 2012?
Your answer should be very brief. 1.76e+07. What is the difference between the Net Disbursements (current US$) of Sub-Saharan Africa (developing only) in 2011 and the Net Disbursements (current US$) of Nepal in 2012?
Your answer should be compact. 8.02e+06. What is the average Net Disbursements (current US$) of Heavily indebted poor countries per year?
Your answer should be very brief. 2.08e+07. What is the average Net Disbursements (current US$) in Sub-Saharan Africa (developing only) per year?
Give a very brief answer. 7.25e+06. What is the average Net Disbursements (current US$) of Colombia per year?
Give a very brief answer. 1.59e+05. What is the average Net Disbursements (current US$) of Nepal per year?
Your answer should be compact. 4.25e+04. In the year 2005, what is the difference between the Net Disbursements (current US$) in Heavily indebted poor countries and Net Disbursements (current US$) in Sub-Saharan Africa (developing only)?
Keep it short and to the point. 8.30e+05. In the year 2005, what is the difference between the Net Disbursements (current US$) of Heavily indebted poor countries and Net Disbursements (current US$) of Colombia?
Offer a very short reply. 4.72e+06. In the year 2005, what is the difference between the Net Disbursements (current US$) of Heavily indebted poor countries and Net Disbursements (current US$) of Nepal?
Provide a succinct answer. 4.82e+06. In the year 2005, what is the difference between the Net Disbursements (current US$) in Sub-Saharan Africa (developing only) and Net Disbursements (current US$) in Colombia?
Provide a short and direct response. 3.89e+06. In the year 2005, what is the difference between the Net Disbursements (current US$) in Sub-Saharan Africa (developing only) and Net Disbursements (current US$) in Nepal?
Provide a short and direct response. 3.99e+06. In the year 2006, what is the difference between the Net Disbursements (current US$) of Heavily indebted poor countries and Net Disbursements (current US$) of Sub-Saharan Africa (developing only)?
Ensure brevity in your answer.  2.60e+06. In the year 2006, what is the difference between the Net Disbursements (current US$) of Heavily indebted poor countries and Net Disbursements (current US$) of Colombia?
Your answer should be compact. 8.01e+06. In the year 2006, what is the difference between the Net Disbursements (current US$) of Heavily indebted poor countries and Net Disbursements (current US$) of Nepal?
Give a very brief answer. 8.31e+06. In the year 2006, what is the difference between the Net Disbursements (current US$) in Sub-Saharan Africa (developing only) and Net Disbursements (current US$) in Colombia?
Offer a very short reply. 5.41e+06. In the year 2006, what is the difference between the Net Disbursements (current US$) in Sub-Saharan Africa (developing only) and Net Disbursements (current US$) in Nepal?
Your response must be concise. 5.71e+06. In the year 2006, what is the difference between the Net Disbursements (current US$) of Colombia and Net Disbursements (current US$) of Nepal?
Provide a succinct answer. 3.00e+05. In the year 2007, what is the difference between the Net Disbursements (current US$) of Heavily indebted poor countries and Net Disbursements (current US$) of Sub-Saharan Africa (developing only)?
Offer a very short reply. 8.01e+06. In the year 2007, what is the difference between the Net Disbursements (current US$) in Heavily indebted poor countries and Net Disbursements (current US$) in Colombia?
Make the answer very short. 1.44e+07. In the year 2007, what is the difference between the Net Disbursements (current US$) in Heavily indebted poor countries and Net Disbursements (current US$) in Nepal?
Offer a terse response. 1.45e+07. In the year 2007, what is the difference between the Net Disbursements (current US$) of Sub-Saharan Africa (developing only) and Net Disbursements (current US$) of Colombia?
Offer a very short reply. 6.42e+06. In the year 2007, what is the difference between the Net Disbursements (current US$) of Sub-Saharan Africa (developing only) and Net Disbursements (current US$) of Nepal?
Ensure brevity in your answer.  6.48e+06. In the year 2008, what is the difference between the Net Disbursements (current US$) in Heavily indebted poor countries and Net Disbursements (current US$) in Sub-Saharan Africa (developing only)?
Provide a succinct answer. 3.94e+07. In the year 2008, what is the difference between the Net Disbursements (current US$) of Heavily indebted poor countries and Net Disbursements (current US$) of Colombia?
Keep it short and to the point. 4.86e+07. In the year 2008, what is the difference between the Net Disbursements (current US$) in Heavily indebted poor countries and Net Disbursements (current US$) in Nepal?
Give a very brief answer. 4.88e+07. In the year 2008, what is the difference between the Net Disbursements (current US$) in Sub-Saharan Africa (developing only) and Net Disbursements (current US$) in Colombia?
Give a very brief answer. 9.25e+06. In the year 2008, what is the difference between the Net Disbursements (current US$) of Sub-Saharan Africa (developing only) and Net Disbursements (current US$) of Nepal?
Give a very brief answer. 9.41e+06. In the year 2008, what is the difference between the Net Disbursements (current US$) in Colombia and Net Disbursements (current US$) in Nepal?
Ensure brevity in your answer.  1.60e+05. In the year 2009, what is the difference between the Net Disbursements (current US$) of Heavily indebted poor countries and Net Disbursements (current US$) of Sub-Saharan Africa (developing only)?
Ensure brevity in your answer.  2.33e+07. In the year 2009, what is the difference between the Net Disbursements (current US$) in Heavily indebted poor countries and Net Disbursements (current US$) in Colombia?
Your answer should be very brief. 3.27e+07. In the year 2009, what is the difference between the Net Disbursements (current US$) of Heavily indebted poor countries and Net Disbursements (current US$) of Nepal?
Your answer should be very brief. 3.28e+07. In the year 2009, what is the difference between the Net Disbursements (current US$) in Sub-Saharan Africa (developing only) and Net Disbursements (current US$) in Colombia?
Give a very brief answer. 9.39e+06. In the year 2009, what is the difference between the Net Disbursements (current US$) in Sub-Saharan Africa (developing only) and Net Disbursements (current US$) in Nepal?
Provide a succinct answer. 9.52e+06. In the year 2010, what is the difference between the Net Disbursements (current US$) in Heavily indebted poor countries and Net Disbursements (current US$) in Sub-Saharan Africa (developing only)?
Offer a very short reply. 1.29e+07. In the year 2010, what is the difference between the Net Disbursements (current US$) of Heavily indebted poor countries and Net Disbursements (current US$) of Colombia?
Offer a terse response. 2.03e+07. In the year 2010, what is the difference between the Net Disbursements (current US$) in Heavily indebted poor countries and Net Disbursements (current US$) in Nepal?
Make the answer very short. 2.04e+07. In the year 2010, what is the difference between the Net Disbursements (current US$) in Sub-Saharan Africa (developing only) and Net Disbursements (current US$) in Colombia?
Give a very brief answer. 7.39e+06. In the year 2010, what is the difference between the Net Disbursements (current US$) in Sub-Saharan Africa (developing only) and Net Disbursements (current US$) in Nepal?
Your response must be concise. 7.50e+06. In the year 2011, what is the difference between the Net Disbursements (current US$) of Heavily indebted poor countries and Net Disbursements (current US$) of Sub-Saharan Africa (developing only)?
Keep it short and to the point. 9.59e+06. In the year 2011, what is the difference between the Net Disbursements (current US$) of Heavily indebted poor countries and Net Disbursements (current US$) of Colombia?
Provide a short and direct response. 1.76e+07. In the year 2011, what is the difference between the Net Disbursements (current US$) of Heavily indebted poor countries and Net Disbursements (current US$) of Nepal?
Keep it short and to the point. 1.76e+07. In the year 2011, what is the difference between the Net Disbursements (current US$) in Sub-Saharan Africa (developing only) and Net Disbursements (current US$) in Colombia?
Keep it short and to the point. 7.98e+06. In the year 2011, what is the difference between the Net Disbursements (current US$) in Sub-Saharan Africa (developing only) and Net Disbursements (current US$) in Nepal?
Make the answer very short. 8.03e+06. In the year 2011, what is the difference between the Net Disbursements (current US$) in Colombia and Net Disbursements (current US$) in Nepal?
Offer a very short reply. 5.00e+04. In the year 2012, what is the difference between the Net Disbursements (current US$) of Heavily indebted poor countries and Net Disbursements (current US$) of Sub-Saharan Africa (developing only)?
Provide a short and direct response. 1.15e+07. In the year 2012, what is the difference between the Net Disbursements (current US$) in Heavily indebted poor countries and Net Disbursements (current US$) in Colombia?
Give a very brief answer. 1.85e+07. In the year 2012, what is the difference between the Net Disbursements (current US$) in Heavily indebted poor countries and Net Disbursements (current US$) in Nepal?
Your answer should be compact. 1.85e+07. In the year 2012, what is the difference between the Net Disbursements (current US$) of Sub-Saharan Africa (developing only) and Net Disbursements (current US$) of Colombia?
Your answer should be very brief. 7.00e+06. In the year 2012, what is the difference between the Net Disbursements (current US$) of Sub-Saharan Africa (developing only) and Net Disbursements (current US$) of Nepal?
Offer a very short reply. 7.02e+06. In the year 2012, what is the difference between the Net Disbursements (current US$) of Colombia and Net Disbursements (current US$) of Nepal?
Keep it short and to the point. 2.00e+04. What is the ratio of the Net Disbursements (current US$) in Heavily indebted poor countries in 2005 to that in 2006?
Make the answer very short. 0.58. What is the ratio of the Net Disbursements (current US$) in Sub-Saharan Africa (developing only) in 2005 to that in 2006?
Your answer should be very brief. 0.7. What is the ratio of the Net Disbursements (current US$) of Colombia in 2005 to that in 2006?
Provide a short and direct response. 0.36. What is the ratio of the Net Disbursements (current US$) of Nepal in 2005 to that in 2006?
Offer a terse response. 0.67. What is the ratio of the Net Disbursements (current US$) in Heavily indebted poor countries in 2005 to that in 2007?
Your answer should be compact. 0.33. What is the ratio of the Net Disbursements (current US$) in Sub-Saharan Africa (developing only) in 2005 to that in 2007?
Your answer should be compact. 0.61. What is the ratio of the Net Disbursements (current US$) in Colombia in 2005 to that in 2007?
Your answer should be very brief. 0.71. What is the ratio of the Net Disbursements (current US$) in Nepal in 2005 to that in 2007?
Give a very brief answer. 0.18. What is the ratio of the Net Disbursements (current US$) of Heavily indebted poor countries in 2005 to that in 2008?
Your answer should be very brief. 0.1. What is the ratio of the Net Disbursements (current US$) of Sub-Saharan Africa (developing only) in 2005 to that in 2008?
Your response must be concise. 0.42. What is the ratio of the Net Disbursements (current US$) in Colombia in 2005 to that in 2008?
Make the answer very short. 0.63. What is the ratio of the Net Disbursements (current US$) in Nepal in 2005 to that in 2008?
Give a very brief answer. 0.67. What is the ratio of the Net Disbursements (current US$) in Heavily indebted poor countries in 2005 to that in 2009?
Your response must be concise. 0.15. What is the ratio of the Net Disbursements (current US$) of Sub-Saharan Africa (developing only) in 2005 to that in 2009?
Provide a succinct answer. 0.42. What is the ratio of the Net Disbursements (current US$) in Colombia in 2005 to that in 2009?
Ensure brevity in your answer.  0.75. What is the ratio of the Net Disbursements (current US$) of Nepal in 2005 to that in 2009?
Keep it short and to the point. 0.67. What is the ratio of the Net Disbursements (current US$) of Heavily indebted poor countries in 2005 to that in 2010?
Your answer should be compact. 0.24. What is the ratio of the Net Disbursements (current US$) of Sub-Saharan Africa (developing only) in 2005 to that in 2010?
Provide a succinct answer. 0.53. What is the ratio of the Net Disbursements (current US$) in Colombia in 2005 to that in 2010?
Your response must be concise. 0.86. What is the ratio of the Net Disbursements (current US$) in Heavily indebted poor countries in 2005 to that in 2011?
Your answer should be compact. 0.27. What is the ratio of the Net Disbursements (current US$) in Sub-Saharan Africa (developing only) in 2005 to that in 2011?
Give a very brief answer. 0.5. What is the ratio of the Net Disbursements (current US$) of Colombia in 2005 to that in 2011?
Provide a succinct answer. 1.33. What is the ratio of the Net Disbursements (current US$) in Nepal in 2005 to that in 2011?
Your answer should be very brief. 0.5. What is the ratio of the Net Disbursements (current US$) in Heavily indebted poor countries in 2005 to that in 2012?
Provide a short and direct response. 0.26. What is the ratio of the Net Disbursements (current US$) of Sub-Saharan Africa (developing only) in 2005 to that in 2012?
Keep it short and to the point. 0.57. What is the ratio of the Net Disbursements (current US$) of Colombia in 2005 to that in 2012?
Provide a succinct answer. 1.71. What is the ratio of the Net Disbursements (current US$) in Nepal in 2005 to that in 2012?
Offer a very short reply. 0.4. What is the ratio of the Net Disbursements (current US$) in Heavily indebted poor countries in 2006 to that in 2007?
Ensure brevity in your answer.  0.57. What is the ratio of the Net Disbursements (current US$) in Sub-Saharan Africa (developing only) in 2006 to that in 2007?
Provide a succinct answer. 0.87. What is the ratio of the Net Disbursements (current US$) of Colombia in 2006 to that in 2007?
Your response must be concise. 1.94. What is the ratio of the Net Disbursements (current US$) in Nepal in 2006 to that in 2007?
Ensure brevity in your answer.  0.27. What is the ratio of the Net Disbursements (current US$) in Heavily indebted poor countries in 2006 to that in 2008?
Your answer should be compact. 0.17. What is the ratio of the Net Disbursements (current US$) of Sub-Saharan Africa (developing only) in 2006 to that in 2008?
Give a very brief answer. 0.61. What is the ratio of the Net Disbursements (current US$) in Colombia in 2006 to that in 2008?
Make the answer very short. 1.74. What is the ratio of the Net Disbursements (current US$) in Heavily indebted poor countries in 2006 to that in 2009?
Provide a succinct answer. 0.25. What is the ratio of the Net Disbursements (current US$) of Sub-Saharan Africa (developing only) in 2006 to that in 2009?
Offer a very short reply. 0.6. What is the ratio of the Net Disbursements (current US$) of Colombia in 2006 to that in 2009?
Your answer should be very brief. 2.06. What is the ratio of the Net Disbursements (current US$) in Heavily indebted poor countries in 2006 to that in 2010?
Offer a very short reply. 0.41. What is the ratio of the Net Disbursements (current US$) of Sub-Saharan Africa (developing only) in 2006 to that in 2010?
Keep it short and to the point. 0.76. What is the ratio of the Net Disbursements (current US$) in Colombia in 2006 to that in 2010?
Provide a short and direct response. 2.36. What is the ratio of the Net Disbursements (current US$) of Nepal in 2006 to that in 2010?
Provide a short and direct response. 1. What is the ratio of the Net Disbursements (current US$) of Heavily indebted poor countries in 2006 to that in 2011?
Make the answer very short. 0.47. What is the ratio of the Net Disbursements (current US$) in Sub-Saharan Africa (developing only) in 2006 to that in 2011?
Your response must be concise. 0.71. What is the ratio of the Net Disbursements (current US$) in Colombia in 2006 to that in 2011?
Ensure brevity in your answer.  3.67. What is the ratio of the Net Disbursements (current US$) in Heavily indebted poor countries in 2006 to that in 2012?
Ensure brevity in your answer.  0.45. What is the ratio of the Net Disbursements (current US$) in Sub-Saharan Africa (developing only) in 2006 to that in 2012?
Your answer should be very brief. 0.81. What is the ratio of the Net Disbursements (current US$) of Colombia in 2006 to that in 2012?
Keep it short and to the point. 4.71. What is the ratio of the Net Disbursements (current US$) of Heavily indebted poor countries in 2007 to that in 2008?
Provide a succinct answer. 0.3. What is the ratio of the Net Disbursements (current US$) of Sub-Saharan Africa (developing only) in 2007 to that in 2008?
Give a very brief answer. 0.7. What is the ratio of the Net Disbursements (current US$) in Colombia in 2007 to that in 2008?
Your response must be concise. 0.89. What is the ratio of the Net Disbursements (current US$) in Nepal in 2007 to that in 2008?
Give a very brief answer. 3.67. What is the ratio of the Net Disbursements (current US$) in Heavily indebted poor countries in 2007 to that in 2009?
Your response must be concise. 0.44. What is the ratio of the Net Disbursements (current US$) in Sub-Saharan Africa (developing only) in 2007 to that in 2009?
Your answer should be compact. 0.69. What is the ratio of the Net Disbursements (current US$) of Nepal in 2007 to that in 2009?
Give a very brief answer. 3.67. What is the ratio of the Net Disbursements (current US$) of Heavily indebted poor countries in 2007 to that in 2010?
Provide a succinct answer. 0.71. What is the ratio of the Net Disbursements (current US$) of Sub-Saharan Africa (developing only) in 2007 to that in 2010?
Give a very brief answer. 0.88. What is the ratio of the Net Disbursements (current US$) of Colombia in 2007 to that in 2010?
Your answer should be very brief. 1.21. What is the ratio of the Net Disbursements (current US$) in Nepal in 2007 to that in 2010?
Provide a short and direct response. 3.67. What is the ratio of the Net Disbursements (current US$) of Heavily indebted poor countries in 2007 to that in 2011?
Provide a succinct answer. 0.83. What is the ratio of the Net Disbursements (current US$) in Sub-Saharan Africa (developing only) in 2007 to that in 2011?
Give a very brief answer. 0.82. What is the ratio of the Net Disbursements (current US$) of Colombia in 2007 to that in 2011?
Your response must be concise. 1.89. What is the ratio of the Net Disbursements (current US$) in Nepal in 2007 to that in 2011?
Provide a short and direct response. 2.75. What is the ratio of the Net Disbursements (current US$) of Heavily indebted poor countries in 2007 to that in 2012?
Make the answer very short. 0.79. What is the ratio of the Net Disbursements (current US$) of Sub-Saharan Africa (developing only) in 2007 to that in 2012?
Your answer should be compact. 0.93. What is the ratio of the Net Disbursements (current US$) of Colombia in 2007 to that in 2012?
Provide a short and direct response. 2.43. What is the ratio of the Net Disbursements (current US$) of Nepal in 2007 to that in 2012?
Keep it short and to the point. 2.2. What is the ratio of the Net Disbursements (current US$) of Heavily indebted poor countries in 2008 to that in 2009?
Your answer should be compact. 1.49. What is the ratio of the Net Disbursements (current US$) in Colombia in 2008 to that in 2009?
Offer a terse response. 1.19. What is the ratio of the Net Disbursements (current US$) in Heavily indebted poor countries in 2008 to that in 2010?
Keep it short and to the point. 2.39. What is the ratio of the Net Disbursements (current US$) of Sub-Saharan Africa (developing only) in 2008 to that in 2010?
Make the answer very short. 1.25. What is the ratio of the Net Disbursements (current US$) of Colombia in 2008 to that in 2010?
Give a very brief answer. 1.36. What is the ratio of the Net Disbursements (current US$) in Heavily indebted poor countries in 2008 to that in 2011?
Your response must be concise. 2.76. What is the ratio of the Net Disbursements (current US$) in Sub-Saharan Africa (developing only) in 2008 to that in 2011?
Your answer should be very brief. 1.17. What is the ratio of the Net Disbursements (current US$) of Colombia in 2008 to that in 2011?
Your answer should be compact. 2.11. What is the ratio of the Net Disbursements (current US$) in Nepal in 2008 to that in 2011?
Provide a short and direct response. 0.75. What is the ratio of the Net Disbursements (current US$) in Heavily indebted poor countries in 2008 to that in 2012?
Your answer should be very brief. 2.63. What is the ratio of the Net Disbursements (current US$) of Sub-Saharan Africa (developing only) in 2008 to that in 2012?
Keep it short and to the point. 1.34. What is the ratio of the Net Disbursements (current US$) in Colombia in 2008 to that in 2012?
Your response must be concise. 2.71. What is the ratio of the Net Disbursements (current US$) of Heavily indebted poor countries in 2009 to that in 2010?
Provide a short and direct response. 1.61. What is the ratio of the Net Disbursements (current US$) of Sub-Saharan Africa (developing only) in 2009 to that in 2010?
Your answer should be compact. 1.27. What is the ratio of the Net Disbursements (current US$) of Heavily indebted poor countries in 2009 to that in 2011?
Your answer should be compact. 1.86. What is the ratio of the Net Disbursements (current US$) of Sub-Saharan Africa (developing only) in 2009 to that in 2011?
Make the answer very short. 1.18. What is the ratio of the Net Disbursements (current US$) in Colombia in 2009 to that in 2011?
Your response must be concise. 1.78. What is the ratio of the Net Disbursements (current US$) of Nepal in 2009 to that in 2011?
Give a very brief answer. 0.75. What is the ratio of the Net Disbursements (current US$) of Heavily indebted poor countries in 2009 to that in 2012?
Offer a terse response. 1.77. What is the ratio of the Net Disbursements (current US$) in Sub-Saharan Africa (developing only) in 2009 to that in 2012?
Offer a terse response. 1.35. What is the ratio of the Net Disbursements (current US$) in Colombia in 2009 to that in 2012?
Your response must be concise. 2.29. What is the ratio of the Net Disbursements (current US$) of Heavily indebted poor countries in 2010 to that in 2011?
Offer a very short reply. 1.16. What is the ratio of the Net Disbursements (current US$) in Sub-Saharan Africa (developing only) in 2010 to that in 2011?
Ensure brevity in your answer.  0.93. What is the ratio of the Net Disbursements (current US$) of Colombia in 2010 to that in 2011?
Keep it short and to the point. 1.56. What is the ratio of the Net Disbursements (current US$) of Nepal in 2010 to that in 2011?
Your answer should be compact. 0.75. What is the ratio of the Net Disbursements (current US$) in Heavily indebted poor countries in 2010 to that in 2012?
Your response must be concise. 1.1. What is the ratio of the Net Disbursements (current US$) in Sub-Saharan Africa (developing only) in 2010 to that in 2012?
Your answer should be compact. 1.07. What is the ratio of the Net Disbursements (current US$) of Nepal in 2010 to that in 2012?
Ensure brevity in your answer.  0.6. What is the ratio of the Net Disbursements (current US$) of Heavily indebted poor countries in 2011 to that in 2012?
Offer a very short reply. 0.95. What is the ratio of the Net Disbursements (current US$) of Sub-Saharan Africa (developing only) in 2011 to that in 2012?
Keep it short and to the point. 1.14. What is the difference between the highest and the second highest Net Disbursements (current US$) of Heavily indebted poor countries?
Your response must be concise. 1.60e+07. What is the difference between the highest and the lowest Net Disbursements (current US$) in Heavily indebted poor countries?
Your answer should be compact. 4.40e+07. What is the difference between the highest and the lowest Net Disbursements (current US$) of Sub-Saharan Africa (developing only)?
Your response must be concise. 5.54e+06. 